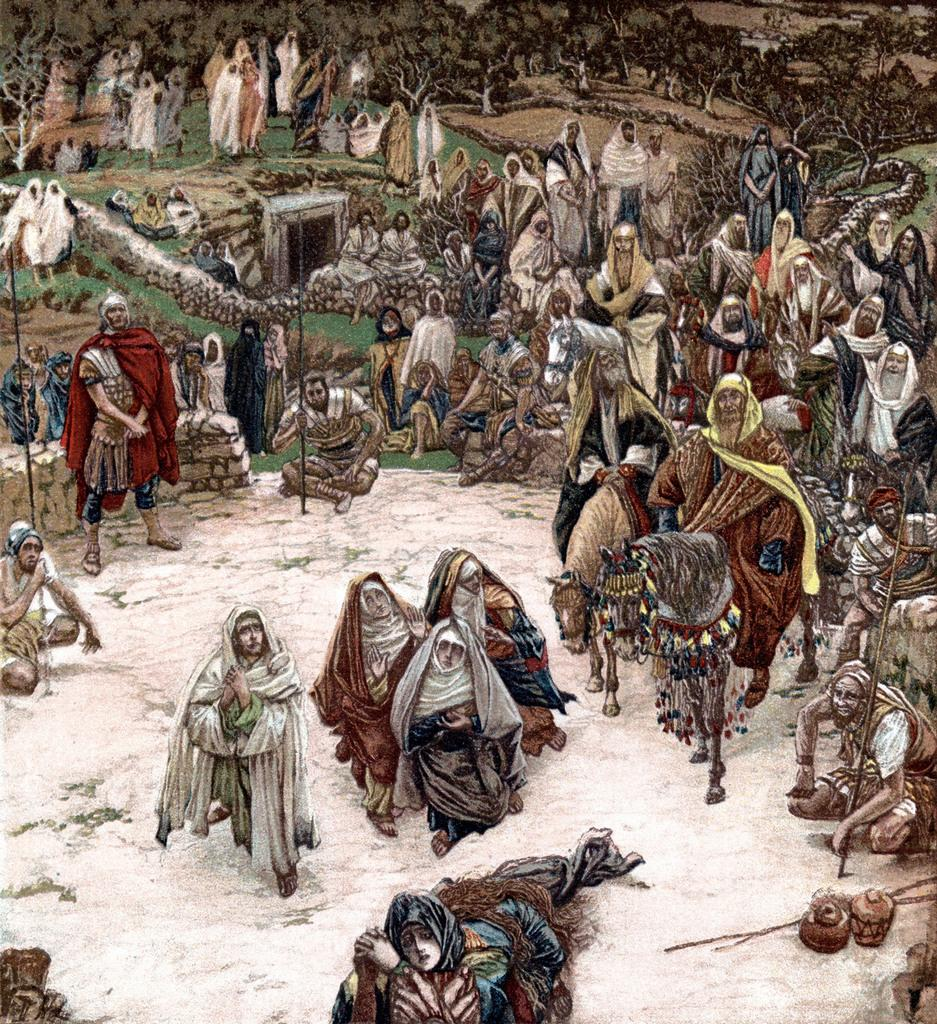What types of living beings are depicted in the sketch? The sketch contains people and horses. What can be seen in the background of the sketch? There are trees in the background of the sketch. What type of store is depicted in the sketch? There is no store depicted in the sketch; it contains people, horses, and trees. What cause is being addressed in the sketch? The sketch does not address any specific cause; it is a depiction of people, horses, and trees. 